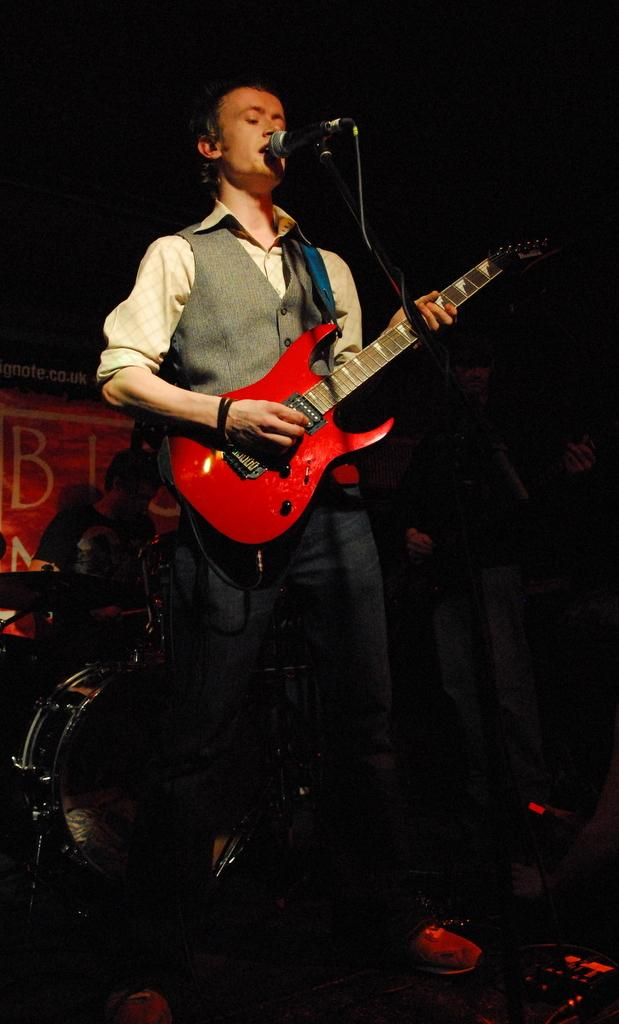How many people are in the image? There are two persons in the image. What are the persons holding in the image? Both persons are holding guitars. Can you describe the position of one of the persons in the image? One person is standing in front of a microphone stand. What is the other person doing in the image? The other person is playing a musical instrument. What type of hook can be seen hanging from the ceiling in the image? There is no hook visible in the image. Are there any bears present in the image? No, there are no bears present in the image. 